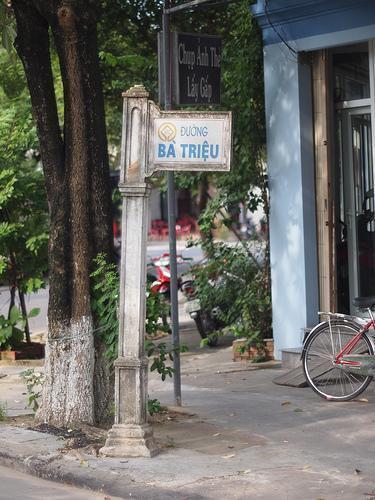How many sign posts are visible?
Give a very brief answer. 2. 